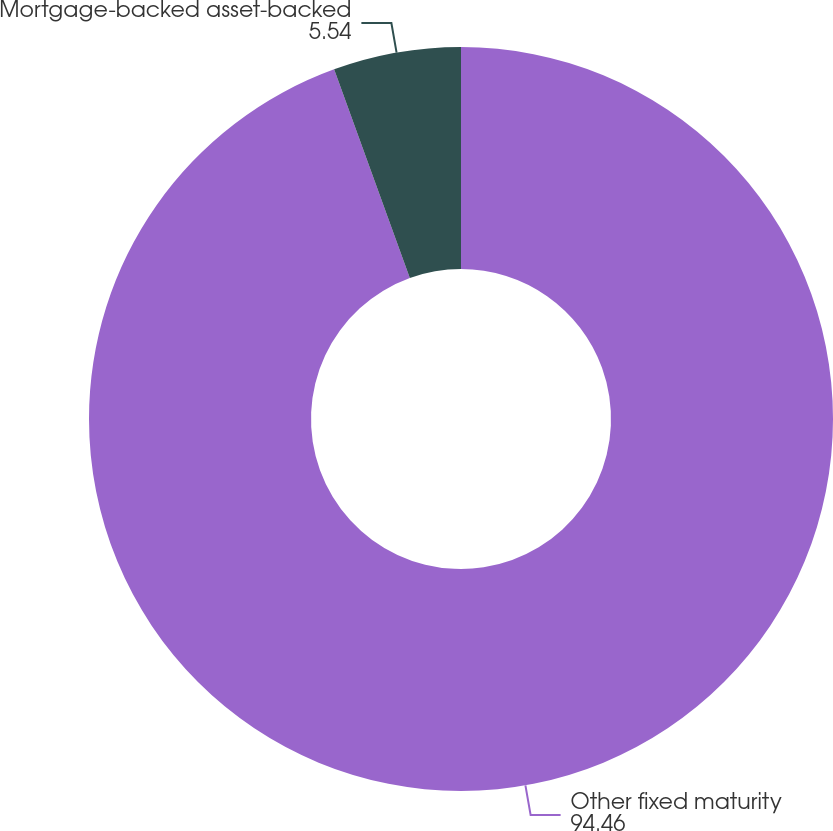<chart> <loc_0><loc_0><loc_500><loc_500><pie_chart><fcel>Other fixed maturity<fcel>Mortgage-backed asset-backed<nl><fcel>94.46%<fcel>5.54%<nl></chart> 